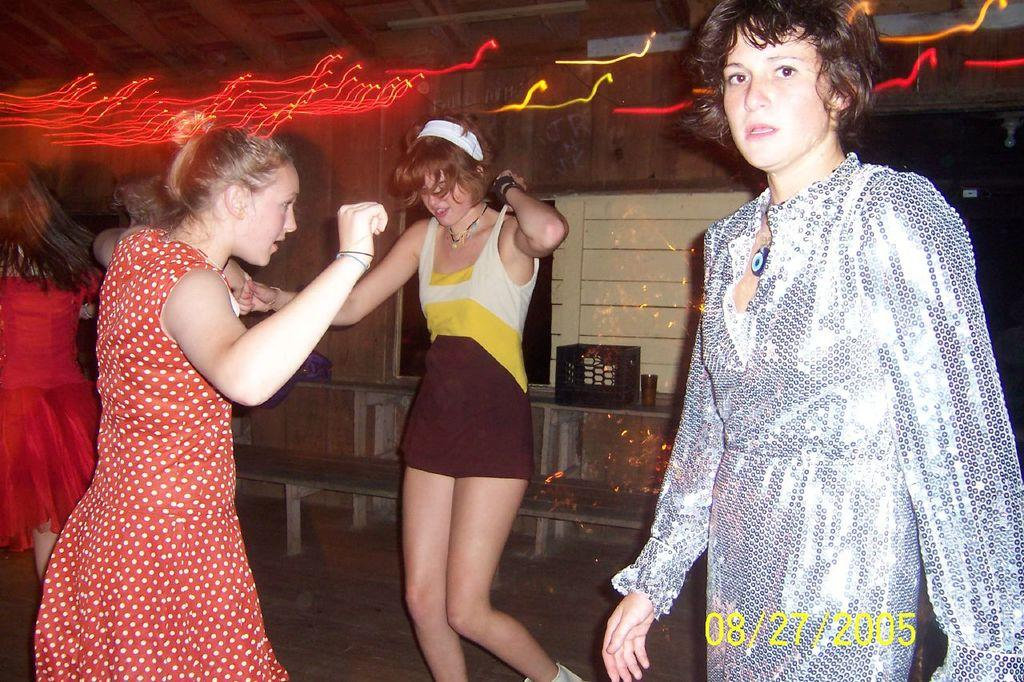How many people are in the image? There are three ladies in the image. What are the ladies doing in the image? The ladies are dancing on the floor. What can be seen in the background of the image? There is a wall in the background of the image. What is on the wall in the image? The wall has a self on it and there are objects on the wall. What type of marble is used to decorate the hat in the image? There is no hat present in the image, and therefore no marble can be associated with it. 